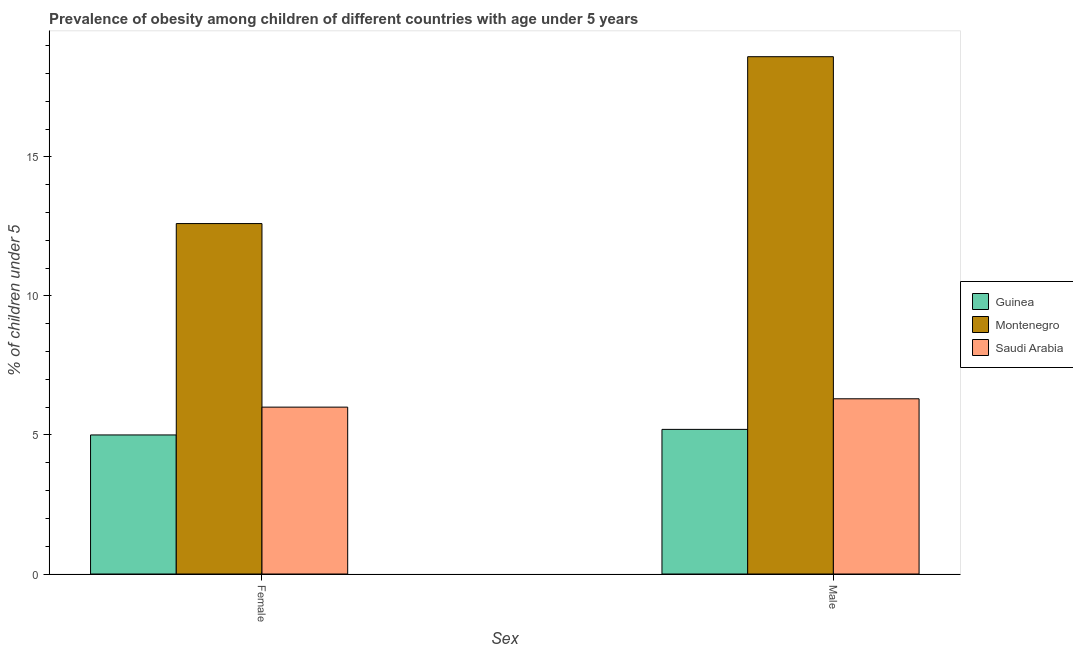Are the number of bars per tick equal to the number of legend labels?
Offer a very short reply. Yes. How many bars are there on the 2nd tick from the right?
Ensure brevity in your answer.  3. What is the percentage of obese male children in Montenegro?
Your answer should be compact. 18.6. Across all countries, what is the maximum percentage of obese male children?
Offer a very short reply. 18.6. Across all countries, what is the minimum percentage of obese male children?
Offer a very short reply. 5.2. In which country was the percentage of obese male children maximum?
Make the answer very short. Montenegro. In which country was the percentage of obese male children minimum?
Offer a very short reply. Guinea. What is the total percentage of obese female children in the graph?
Your answer should be very brief. 23.6. What is the difference between the percentage of obese male children in Saudi Arabia and that in Montenegro?
Provide a succinct answer. -12.3. What is the difference between the percentage of obese female children in Montenegro and the percentage of obese male children in Saudi Arabia?
Ensure brevity in your answer.  6.3. What is the average percentage of obese female children per country?
Your answer should be very brief. 7.87. What is the difference between the percentage of obese male children and percentage of obese female children in Montenegro?
Make the answer very short. 6. In how many countries, is the percentage of obese male children greater than 14 %?
Your answer should be very brief. 1. What is the ratio of the percentage of obese male children in Saudi Arabia to that in Guinea?
Provide a succinct answer. 1.21. Is the percentage of obese female children in Saudi Arabia less than that in Guinea?
Ensure brevity in your answer.  No. In how many countries, is the percentage of obese male children greater than the average percentage of obese male children taken over all countries?
Ensure brevity in your answer.  1. What does the 1st bar from the left in Female represents?
Provide a short and direct response. Guinea. What does the 3rd bar from the right in Male represents?
Offer a very short reply. Guinea. How many bars are there?
Your answer should be very brief. 6. What is the difference between two consecutive major ticks on the Y-axis?
Provide a short and direct response. 5. What is the title of the graph?
Make the answer very short. Prevalence of obesity among children of different countries with age under 5 years. What is the label or title of the X-axis?
Offer a very short reply. Sex. What is the label or title of the Y-axis?
Ensure brevity in your answer.   % of children under 5. What is the  % of children under 5 in Guinea in Female?
Offer a very short reply. 5. What is the  % of children under 5 in Montenegro in Female?
Make the answer very short. 12.6. What is the  % of children under 5 in Guinea in Male?
Offer a very short reply. 5.2. What is the  % of children under 5 of Montenegro in Male?
Provide a short and direct response. 18.6. What is the  % of children under 5 of Saudi Arabia in Male?
Provide a short and direct response. 6.3. Across all Sex, what is the maximum  % of children under 5 of Guinea?
Offer a terse response. 5.2. Across all Sex, what is the maximum  % of children under 5 in Montenegro?
Keep it short and to the point. 18.6. Across all Sex, what is the maximum  % of children under 5 in Saudi Arabia?
Keep it short and to the point. 6.3. Across all Sex, what is the minimum  % of children under 5 in Montenegro?
Your answer should be very brief. 12.6. Across all Sex, what is the minimum  % of children under 5 in Saudi Arabia?
Make the answer very short. 6. What is the total  % of children under 5 in Guinea in the graph?
Provide a succinct answer. 10.2. What is the total  % of children under 5 of Montenegro in the graph?
Keep it short and to the point. 31.2. What is the total  % of children under 5 in Saudi Arabia in the graph?
Keep it short and to the point. 12.3. What is the difference between the  % of children under 5 of Montenegro in Female and that in Male?
Provide a short and direct response. -6. What is the average  % of children under 5 in Montenegro per Sex?
Provide a succinct answer. 15.6. What is the average  % of children under 5 in Saudi Arabia per Sex?
Your answer should be compact. 6.15. What is the difference between the  % of children under 5 in Guinea and  % of children under 5 in Montenegro in Female?
Your answer should be very brief. -7.6. What is the difference between the  % of children under 5 in Guinea and  % of children under 5 in Saudi Arabia in Female?
Offer a terse response. -1. What is the difference between the  % of children under 5 in Montenegro and  % of children under 5 in Saudi Arabia in Female?
Keep it short and to the point. 6.6. What is the difference between the  % of children under 5 of Guinea and  % of children under 5 of Montenegro in Male?
Your answer should be very brief. -13.4. What is the difference between the  % of children under 5 in Guinea and  % of children under 5 in Saudi Arabia in Male?
Offer a terse response. -1.1. What is the difference between the  % of children under 5 of Montenegro and  % of children under 5 of Saudi Arabia in Male?
Keep it short and to the point. 12.3. What is the ratio of the  % of children under 5 in Guinea in Female to that in Male?
Offer a terse response. 0.96. What is the ratio of the  % of children under 5 in Montenegro in Female to that in Male?
Provide a short and direct response. 0.68. What is the difference between the highest and the second highest  % of children under 5 in Saudi Arabia?
Keep it short and to the point. 0.3. What is the difference between the highest and the lowest  % of children under 5 of Montenegro?
Provide a succinct answer. 6. What is the difference between the highest and the lowest  % of children under 5 in Saudi Arabia?
Provide a succinct answer. 0.3. 